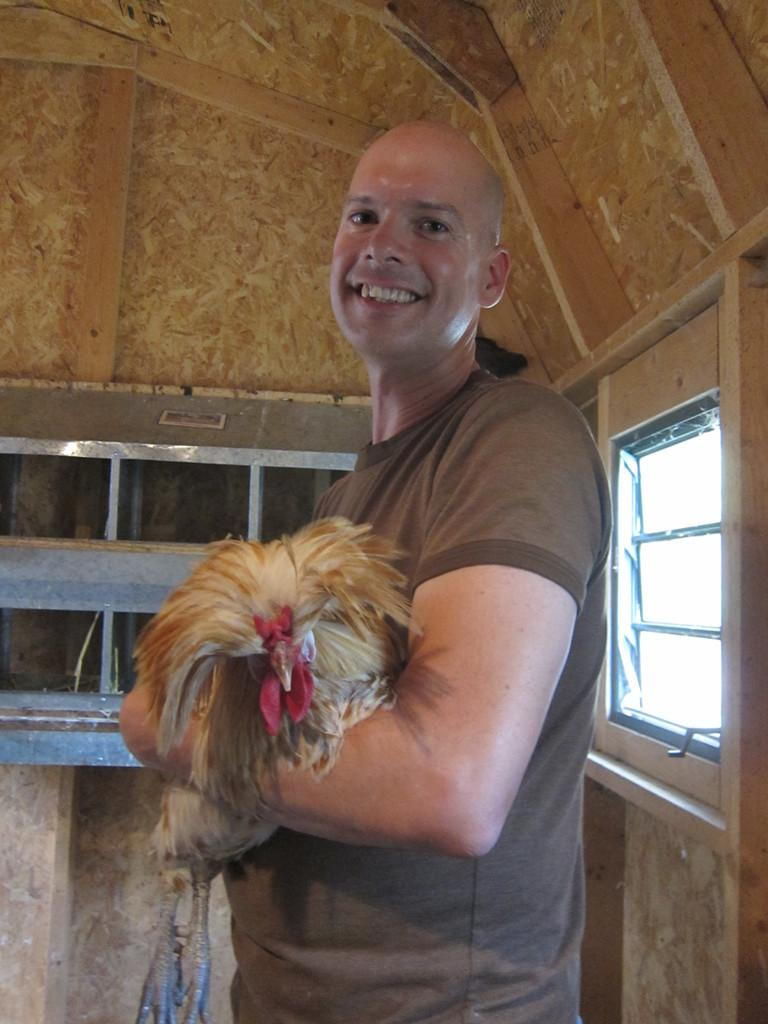What is the person in the image holding? The person is holding a bird in the image. Can you describe the bird's appearance? The bird has brown and red colors. What type of material is the wall visible in the image made of? The wall is made of wood. What architectural feature can be seen in the image? There is a window in the image. What type of stove is visible in the image? There is no stove present in the image. How many fingers does the bird have in the image? Birds do not have fingers; they have wings, feathers, and other bird-specific body parts. 